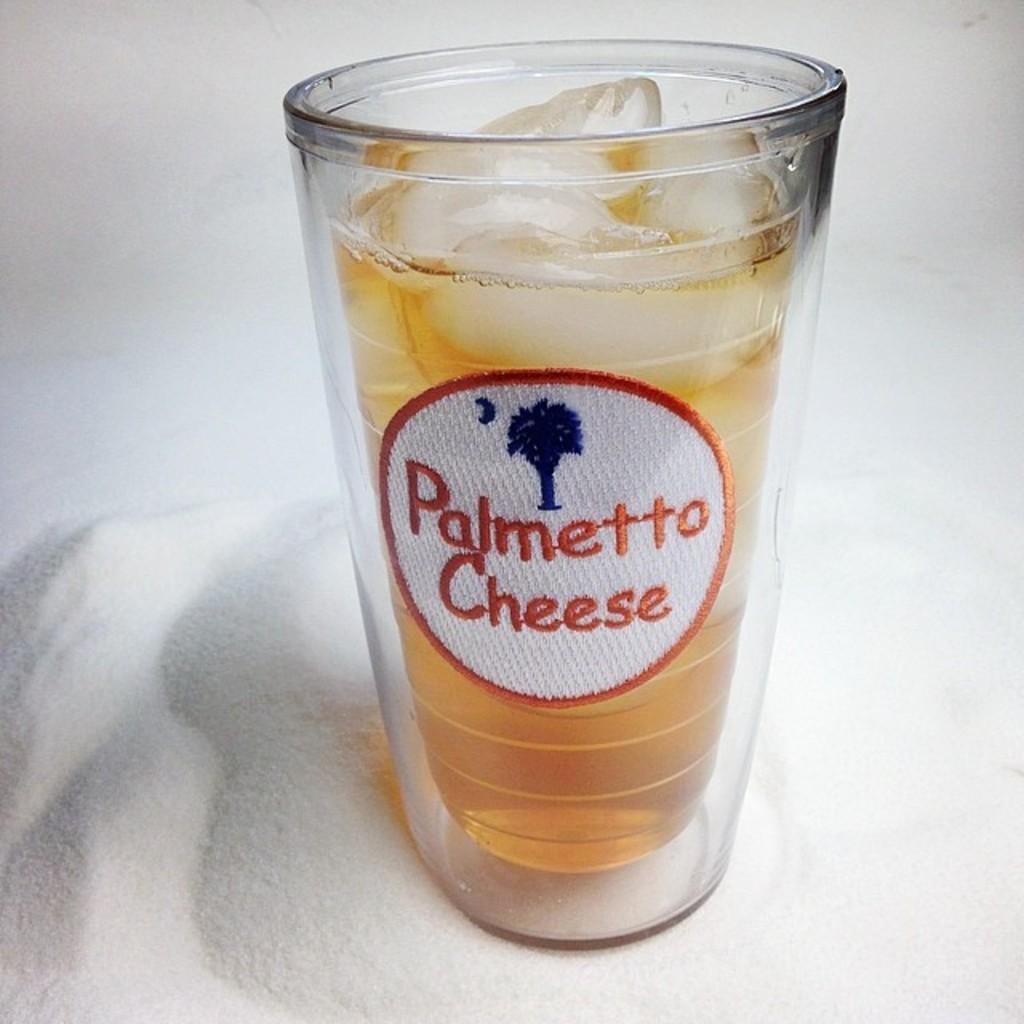Can you describe this image briefly? In this picture there is a wine glass. In the wine glass we can see wine and ice. This glass is kept on the table. 